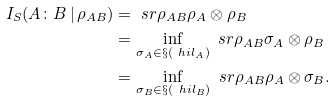Convert formula to latex. <formula><loc_0><loc_0><loc_500><loc_500>I _ { S } ( A \colon B \, | \, \rho _ { A B } ) & = \ s r { \rho _ { A B } } { \rho _ { A } \otimes \rho _ { B } } \\ & = \inf _ { \sigma _ { A } \in \S ( \ h i l _ { A } ) } \ s r { \rho _ { A B } } { \sigma _ { A } \otimes \rho _ { B } } \\ & = \inf _ { \sigma _ { B } \in \S ( \ h i l _ { B } ) } \ s r { \rho _ { A B } } { \rho _ { A } \otimes \sigma _ { B } } .</formula> 